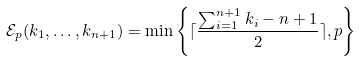Convert formula to latex. <formula><loc_0><loc_0><loc_500><loc_500>\mathcal { E } _ { p } ( k _ { 1 } , \dots , k _ { n + 1 } ) = \min \left \{ \lceil \frac { \sum _ { i = 1 } ^ { n + 1 } k _ { i } - n + 1 } { 2 } \rceil , p \right \}</formula> 